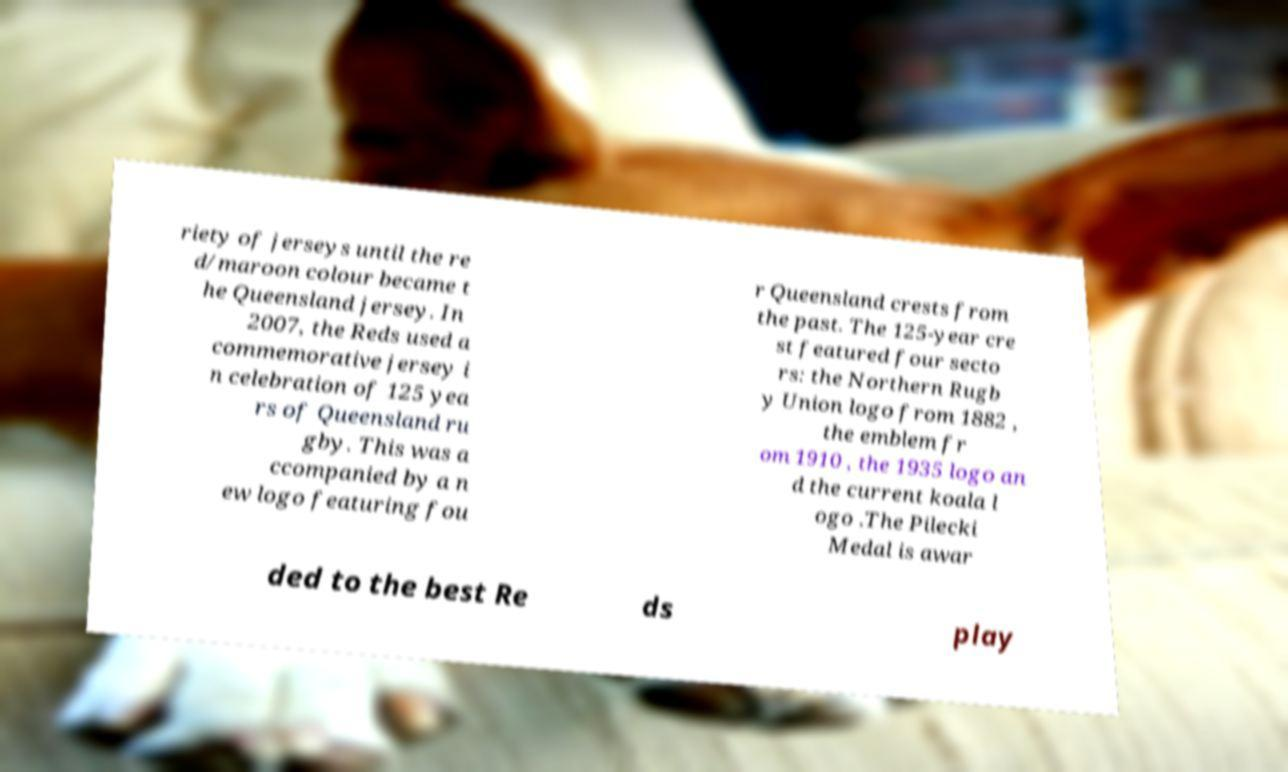Can you read and provide the text displayed in the image?This photo seems to have some interesting text. Can you extract and type it out for me? riety of jerseys until the re d/maroon colour became t he Queensland jersey. In 2007, the Reds used a commemorative jersey i n celebration of 125 yea rs of Queensland ru gby. This was a ccompanied by a n ew logo featuring fou r Queensland crests from the past. The 125-year cre st featured four secto rs: the Northern Rugb y Union logo from 1882 , the emblem fr om 1910 , the 1935 logo an d the current koala l ogo .The Pilecki Medal is awar ded to the best Re ds play 